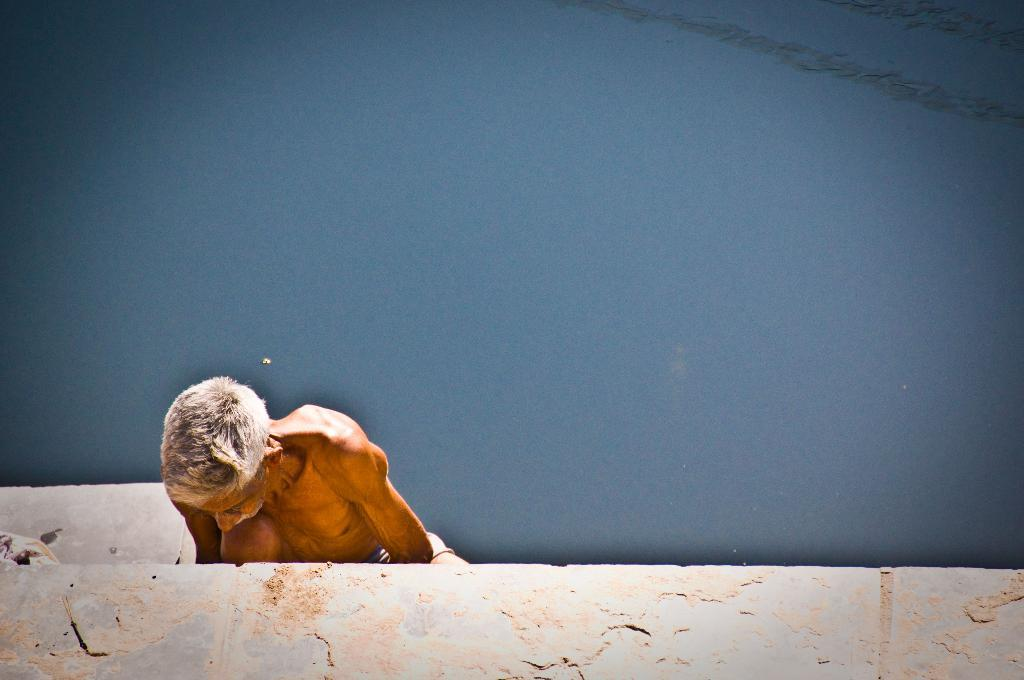Who is present in the image? There is a man in the image. What is located at the bottom of the image? There is a wall at the bottom of the image. What can be seen at the top of the image? There is water visible at the top of the image. What type of request is the man making in the image? There is no indication in the image that the man is making any request. 